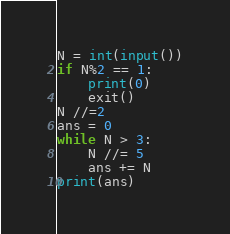<code> <loc_0><loc_0><loc_500><loc_500><_Python_>N = int(input())
if N%2 == 1:
    print(0)
    exit()
N //=2
ans = 0
while N > 3:
    N //= 5
    ans += N
print(ans)</code> 